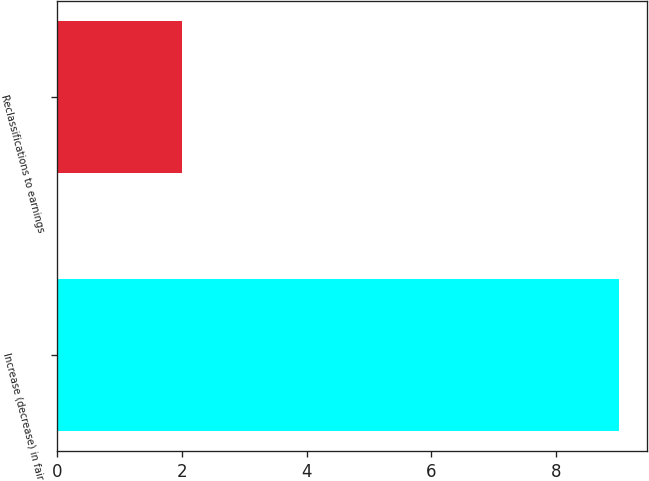Convert chart. <chart><loc_0><loc_0><loc_500><loc_500><bar_chart><fcel>Increase (decrease) in fair<fcel>Reclassifications to earnings<nl><fcel>9<fcel>2<nl></chart> 